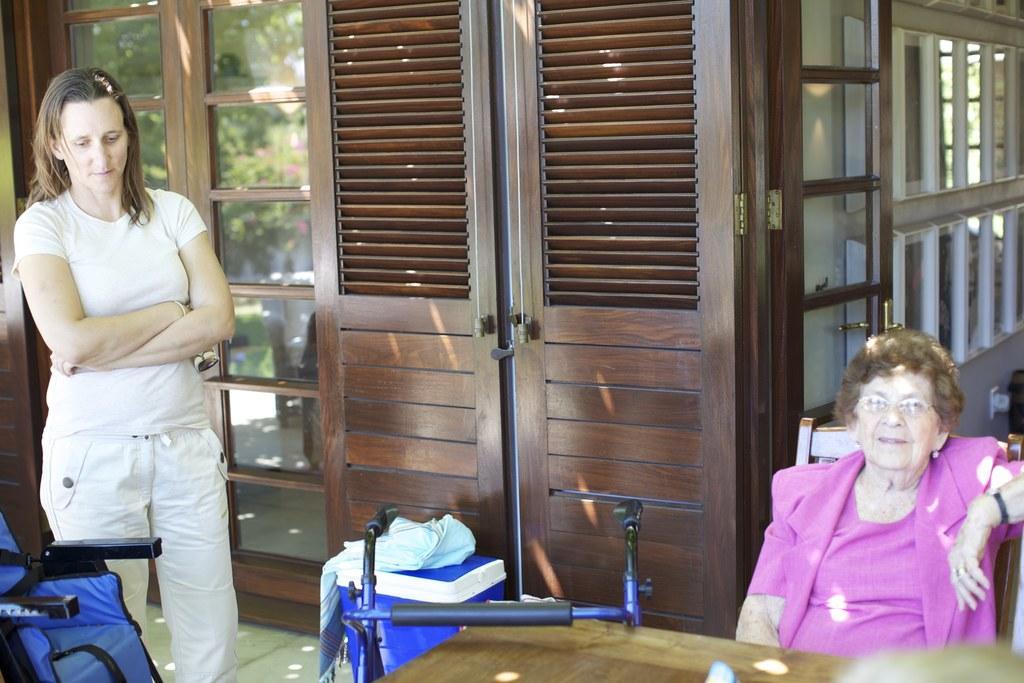In one or two sentences, can you explain what this image depicts? In the background there is a house with walls, windows and wooden doors. On the left side of the image a woman is standing on the floor and there is an empty chair. In the middle of the image there is a table and there is an object. There is a basket and there is a cloth on the basket. On the right side of the image an old woman is sitting on the chair. 